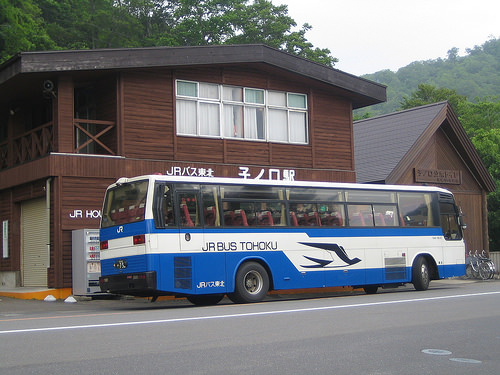<image>
Is there a wall next to the inscription? No. The wall is not positioned next to the inscription. They are located in different areas of the scene. Where is the building in relation to the bus? Is it in front of the bus? No. The building is not in front of the bus. The spatial positioning shows a different relationship between these objects. 